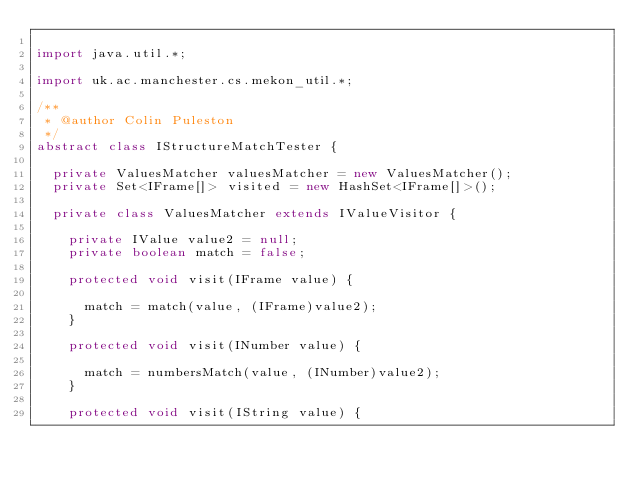<code> <loc_0><loc_0><loc_500><loc_500><_Java_>
import java.util.*;

import uk.ac.manchester.cs.mekon_util.*;

/**
 * @author Colin Puleston
 */
abstract class IStructureMatchTester {

	private ValuesMatcher valuesMatcher = new ValuesMatcher();
	private Set<IFrame[]> visited = new HashSet<IFrame[]>();

	private class ValuesMatcher extends IValueVisitor {

		private IValue value2 = null;
		private boolean match = false;

		protected void visit(IFrame value) {

			match = match(value, (IFrame)value2);
		}

		protected void visit(INumber value) {

			match = numbersMatch(value, (INumber)value2);
		}

		protected void visit(IString value) {
</code> 